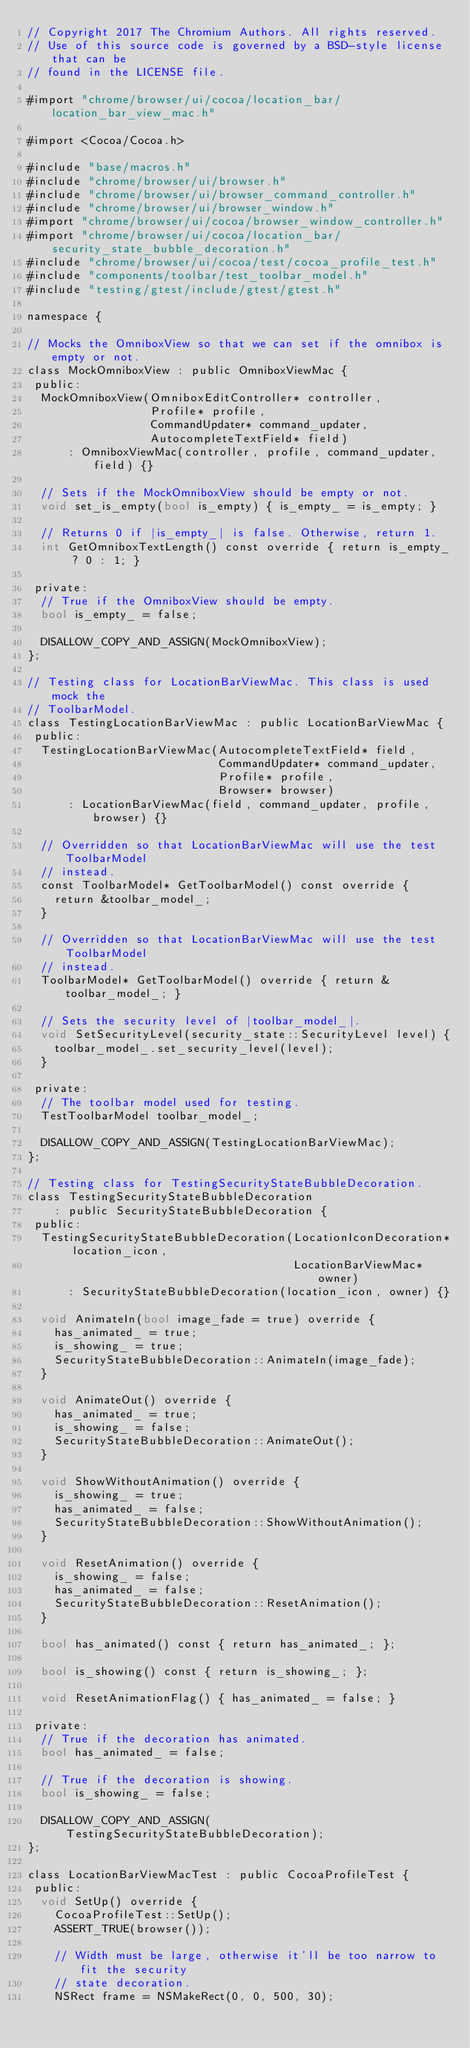<code> <loc_0><loc_0><loc_500><loc_500><_ObjectiveC_>// Copyright 2017 The Chromium Authors. All rights reserved.
// Use of this source code is governed by a BSD-style license that can be
// found in the LICENSE file.

#import "chrome/browser/ui/cocoa/location_bar/location_bar_view_mac.h"

#import <Cocoa/Cocoa.h>

#include "base/macros.h"
#include "chrome/browser/ui/browser.h"
#include "chrome/browser/ui/browser_command_controller.h"
#include "chrome/browser/ui/browser_window.h"
#import "chrome/browser/ui/cocoa/browser_window_controller.h"
#import "chrome/browser/ui/cocoa/location_bar/security_state_bubble_decoration.h"
#include "chrome/browser/ui/cocoa/test/cocoa_profile_test.h"
#include "components/toolbar/test_toolbar_model.h"
#include "testing/gtest/include/gtest/gtest.h"

namespace {

// Mocks the OmniboxView so that we can set if the omnibox is empty or not.
class MockOmniboxView : public OmniboxViewMac {
 public:
  MockOmniboxView(OmniboxEditController* controller,
                  Profile* profile,
                  CommandUpdater* command_updater,
                  AutocompleteTextField* field)
      : OmniboxViewMac(controller, profile, command_updater, field) {}

  // Sets if the MockOmniboxView should be empty or not.
  void set_is_empty(bool is_empty) { is_empty_ = is_empty; }

  // Returns 0 if |is_empty_| is false. Otherwise, return 1.
  int GetOmniboxTextLength() const override { return is_empty_ ? 0 : 1; }

 private:
  // True if the OmniboxView should be empty.
  bool is_empty_ = false;

  DISALLOW_COPY_AND_ASSIGN(MockOmniboxView);
};

// Testing class for LocationBarViewMac. This class is used mock the
// ToolbarModel.
class TestingLocationBarViewMac : public LocationBarViewMac {
 public:
  TestingLocationBarViewMac(AutocompleteTextField* field,
                            CommandUpdater* command_updater,
                            Profile* profile,
                            Browser* browser)
      : LocationBarViewMac(field, command_updater, profile, browser) {}

  // Overridden so that LocationBarViewMac will use the test ToolbarModel
  // instead.
  const ToolbarModel* GetToolbarModel() const override {
    return &toolbar_model_;
  }

  // Overridden so that LocationBarViewMac will use the test ToolbarModel
  // instead.
  ToolbarModel* GetToolbarModel() override { return &toolbar_model_; }

  // Sets the security level of |toolbar_model_|.
  void SetSecurityLevel(security_state::SecurityLevel level) {
    toolbar_model_.set_security_level(level);
  }

 private:
  // The toolbar model used for testing.
  TestToolbarModel toolbar_model_;

  DISALLOW_COPY_AND_ASSIGN(TestingLocationBarViewMac);
};

// Testing class for TestingSecurityStateBubbleDecoration.
class TestingSecurityStateBubbleDecoration
    : public SecurityStateBubbleDecoration {
 public:
  TestingSecurityStateBubbleDecoration(LocationIconDecoration* location_icon,
                                       LocationBarViewMac* owner)
      : SecurityStateBubbleDecoration(location_icon, owner) {}

  void AnimateIn(bool image_fade = true) override {
    has_animated_ = true;
    is_showing_ = true;
    SecurityStateBubbleDecoration::AnimateIn(image_fade);
  }

  void AnimateOut() override {
    has_animated_ = true;
    is_showing_ = false;
    SecurityStateBubbleDecoration::AnimateOut();
  }

  void ShowWithoutAnimation() override {
    is_showing_ = true;
    has_animated_ = false;
    SecurityStateBubbleDecoration::ShowWithoutAnimation();
  }

  void ResetAnimation() override {
    is_showing_ = false;
    has_animated_ = false;
    SecurityStateBubbleDecoration::ResetAnimation();
  }

  bool has_animated() const { return has_animated_; };

  bool is_showing() const { return is_showing_; };

  void ResetAnimationFlag() { has_animated_ = false; }

 private:
  // True if the decoration has animated.
  bool has_animated_ = false;

  // True if the decoration is showing.
  bool is_showing_ = false;

  DISALLOW_COPY_AND_ASSIGN(TestingSecurityStateBubbleDecoration);
};

class LocationBarViewMacTest : public CocoaProfileTest {
 public:
  void SetUp() override {
    CocoaProfileTest::SetUp();
    ASSERT_TRUE(browser());

    // Width must be large, otherwise it'll be too narrow to fit the security
    // state decoration.
    NSRect frame = NSMakeRect(0, 0, 500, 30);</code> 